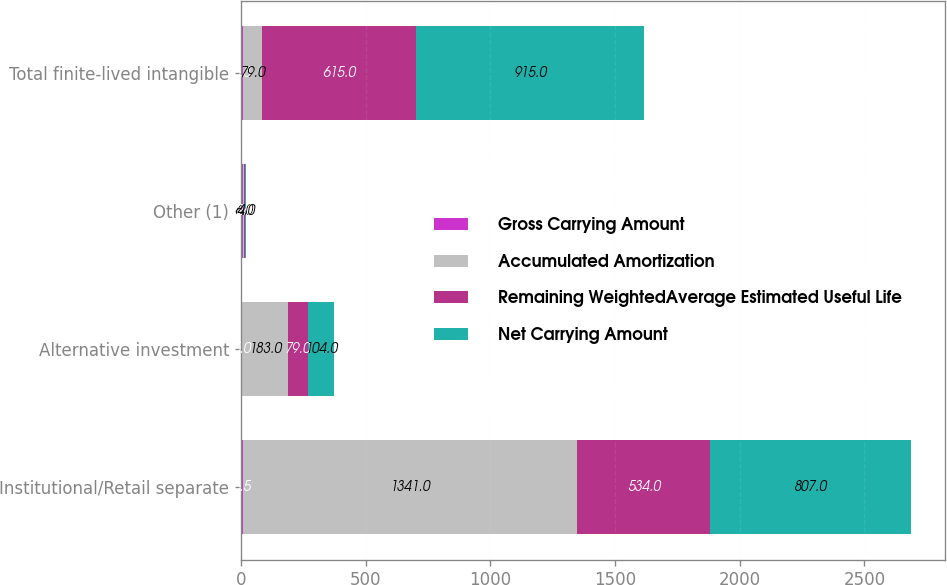<chart> <loc_0><loc_0><loc_500><loc_500><stacked_bar_chart><ecel><fcel>Institutional/Retail separate<fcel>Alternative investment<fcel>Other (1)<fcel>Total finite-lived intangible<nl><fcel>Gross Carrying Amount<fcel>6.5<fcel>5<fcel>7.6<fcel>6.3<nl><fcel>Accumulated Amortization<fcel>1341<fcel>183<fcel>6<fcel>79<nl><fcel>Remaining WeightedAverage Estimated Useful Life<fcel>534<fcel>79<fcel>2<fcel>615<nl><fcel>Net Carrying Amount<fcel>807<fcel>104<fcel>4<fcel>915<nl></chart> 